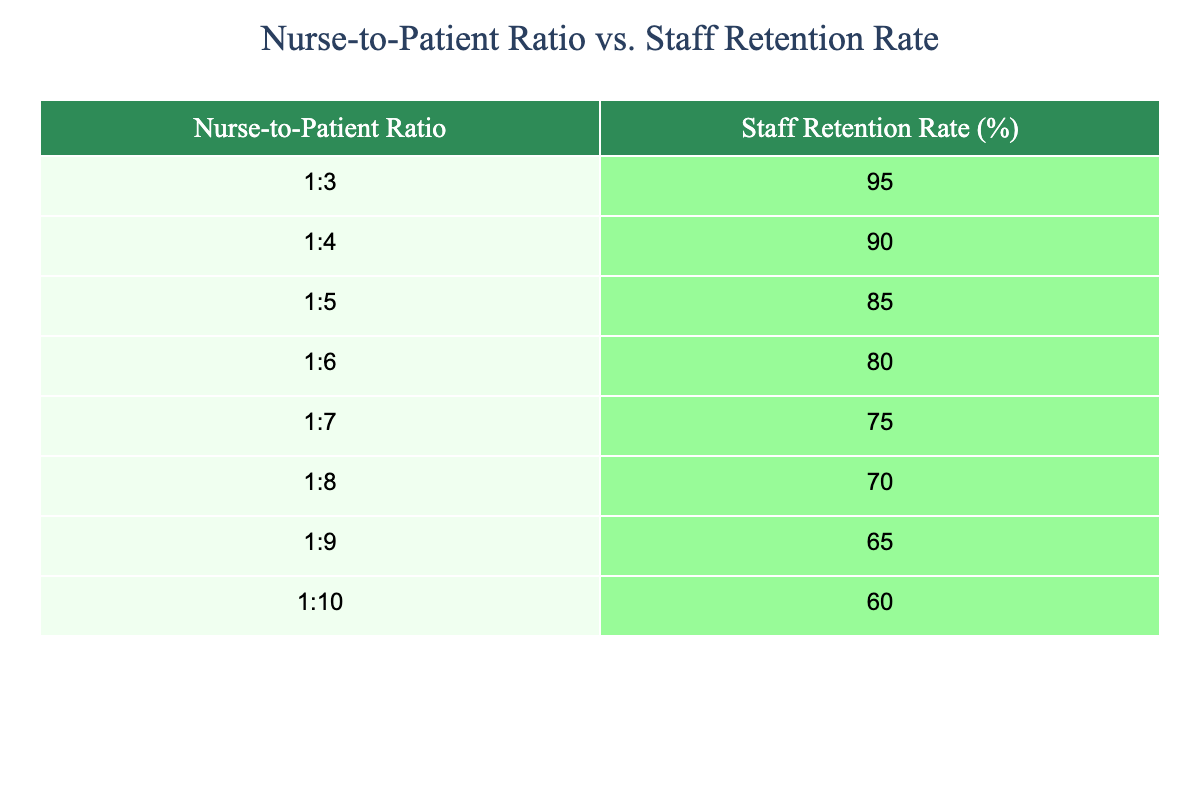What is the staff retention rate for a nurse-to-patient ratio of 1:6? Referring to the table, the nurse-to-patient ratio of 1:6 corresponds to a staff retention rate of 80%.
Answer: 80 What is the nurse-to-patient ratio with the highest staff retention rate? The highest staff retention rate is 95%, which corresponds to a nurse-to-patient ratio of 1:3 as seen in the table.
Answer: 1:3 What is the percentage difference in staff retention rates between a nurse-to-patient ratio of 1:4 and 1:5? The staff retention rate for 1:4 is 90% and for 1:5 it is 85%. The percentage difference is calculated as 90 - 85 = 5, so the difference is 5%.
Answer: 5% Is the staff retention rate higher for a nurse-to-patient ratio of 1:7 than for 1:9? The staff retention rate for a ratio of 1:7 is 75%, and for 1:9 it is 65%. Since 75% is greater than 65%, the statement is true.
Answer: Yes What is the average staff retention rate for nurse-to-patient ratios of 1:3, 1:4, and 1:5? The staff retention rates for these ratios are 95%, 90%, and 85%. First, we find the sum: 95 + 90 + 85 = 270. Then, we divide by the number of ratios (3) to get the average: 270/3 = 90%.
Answer: 90% What is the trend in staff retention rates as the nurse-to-patient ratio increases? Observing the table, as the nurse-to-patient ratio increases from 1:3 to 1:10, the staff retention rates consistently decrease. This indicates a negative trend.
Answer: Negative trend If the goal is to maintain a staff retention rate of at least 80%, which nurse-to-patient ratios meet this criterion? The staff retention rates of 80% or higher are found for ratios of 1:3 (95%), 1:4 (90%), 1:5 (85%), and 1:6 (80%). Thus, the ratios that meet the goal are 1:3, 1:4, 1:5, and 1:6.
Answer: 1:3, 1:4, 1:5, 1:6 What is the lowest staff retention rate recorded in the table? The lowest staff retention rate in the table is 60%, which corresponds to the nurse-to-patient ratio of 1:10.
Answer: 60% 